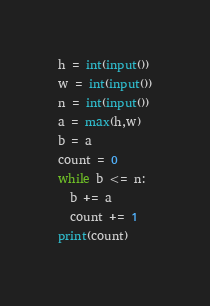<code> <loc_0><loc_0><loc_500><loc_500><_Python_>h = int(input())
w = int(input())
n = int(input())
a = max(h,w)
b = a
count = 0
while b <= n:
  b += a
  count += 1
print(count)</code> 